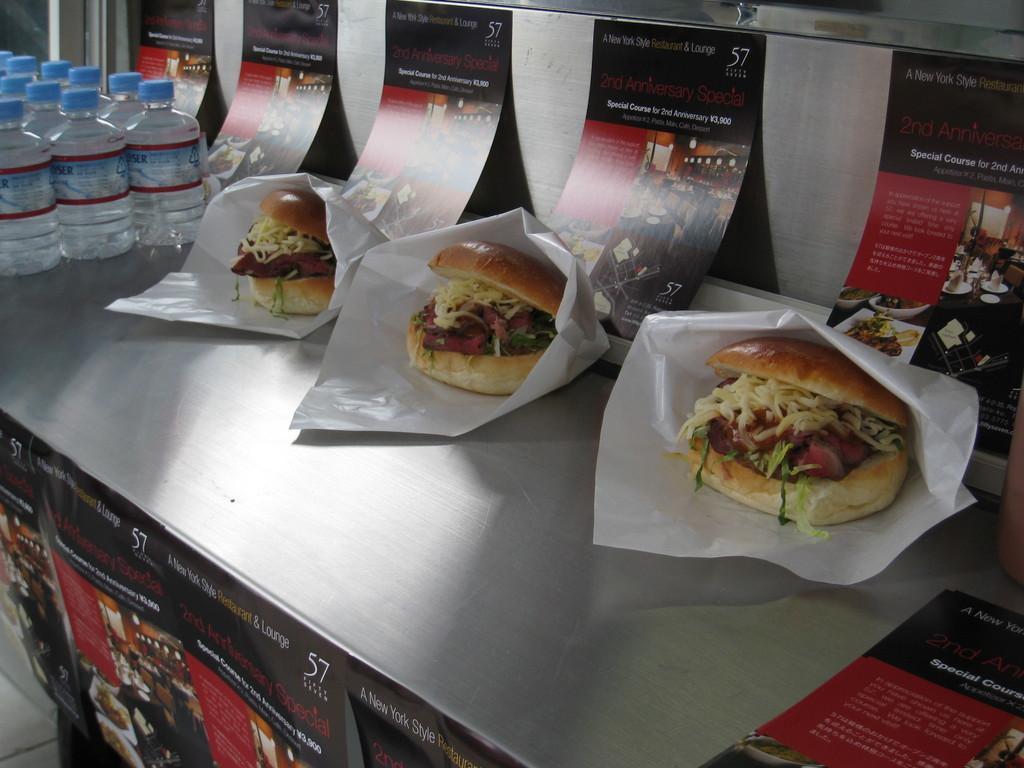Please provide a concise description of this image. In this picture there is a desk in the center of the image, on which there are water bottles and burgers, there are posters at the top and bottom side of the image. 